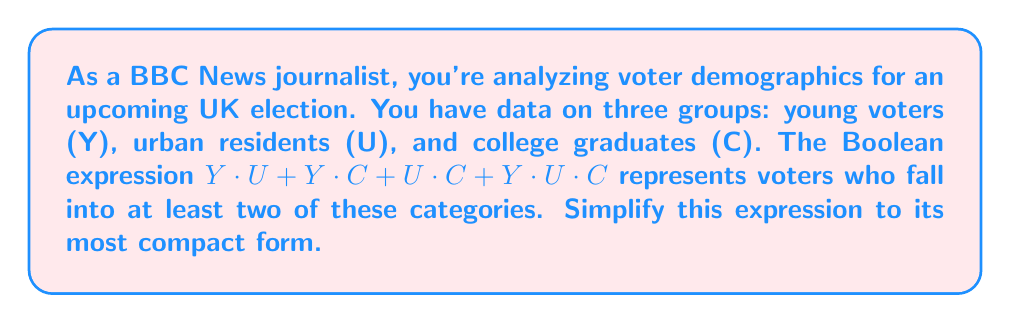Give your solution to this math problem. Let's simplify this Boolean expression step by step:

1) First, let's identify the given expression:
   $$Y \cdot U + Y \cdot C + U \cdot C + Y \cdot U \cdot C$$

2) We can use the absorption law, which states that $A + A \cdot B = A$. In this case, we can absorb the last term $(Y \cdot U \cdot C)$ into the other terms:

   $Y \cdot U + Y \cdot C + U \cdot C + Y \cdot U \cdot C$
   $= Y \cdot U + Y \cdot C + U \cdot C$

3) Now, we can use the distributive law to factor out common terms:

   $= Y \cdot (U + C) + U \cdot C$

4) This is the simplest form of the expression. It represents voters who are either:
   - Young AND (Urban OR College graduates), OR
   - Urban AND College graduates

This simplified form reduces the number of AND operations from four to two, making it more efficient for data processing and analysis.
Answer: $Y \cdot (U + C) + U \cdot C$ 